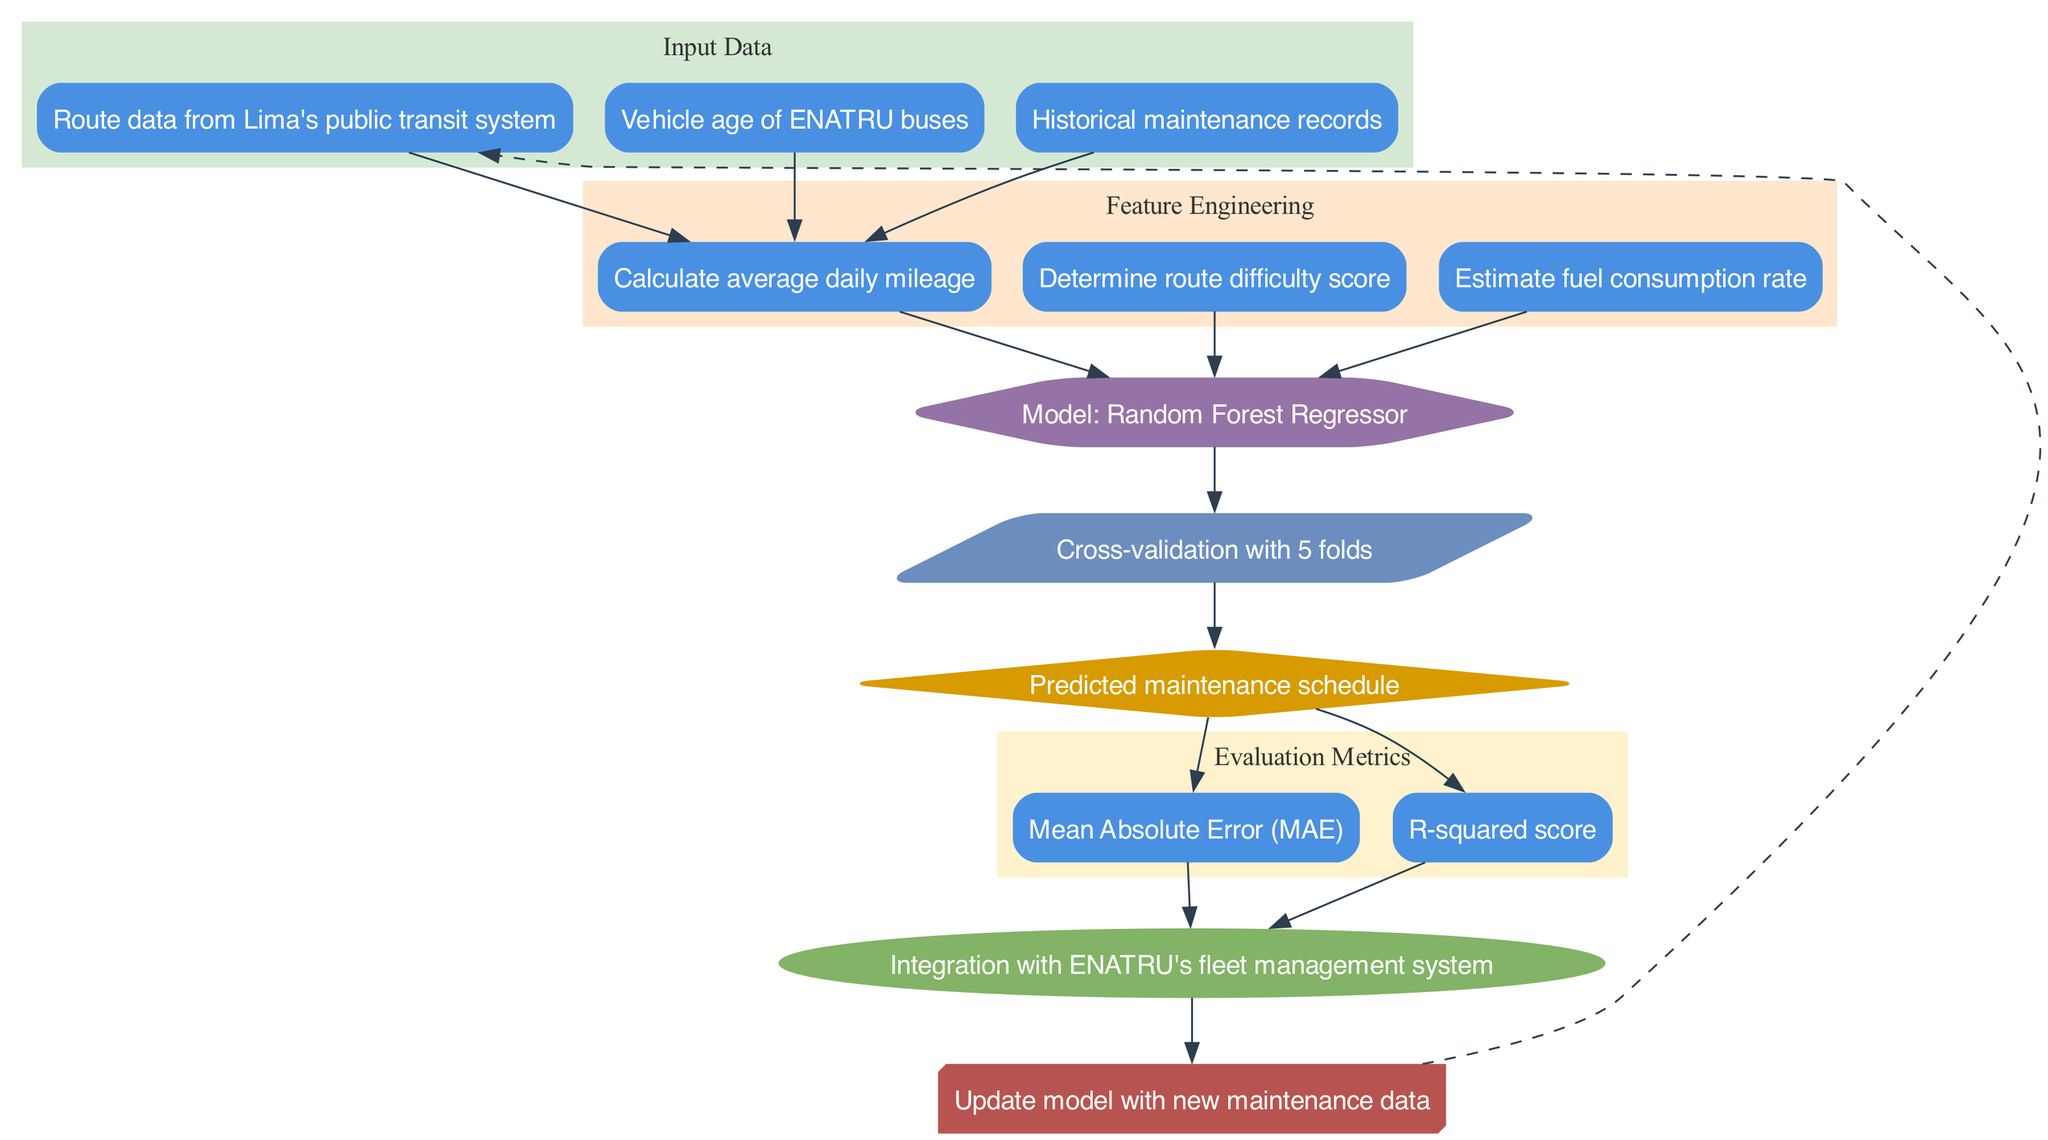What's the model used in the diagram? The diagram specifies "Random Forest Regressor" as the model. This can be identified by locating the node labeled "Model: Random Forest Regressor."
Answer: Random Forest Regressor How many features are engineered in the diagram? The diagram lists three items under the "Feature Engineering" section, which indicates that three features are being engineered.
Answer: 3 What is the evaluation metric for assessing model performance? The diagram includes "Mean Absolute Error (MAE)" as one of the evaluation metrics, which can be found in the Evaluation Metrics cluster.
Answer: Mean Absolute Error What data is used for input in the diagram? The input data includes three items: "Route data from Lima's public transit system," "Vehicle age of ENATRU buses," and "Historical maintenance records." This is evident from the "Input Data" section.
Answer: Route data from Lima's public transit system, Vehicle age of ENATRU buses, Historical maintenance records What is the relationship between the output and the evaluation metrics? In the diagram, the "Predicted maintenance schedule" is connected to both "Mean Absolute Error (MAE)" and "R-squared score," indicating that these metrics are used to evaluate the output of the model.
Answer: The output connects to both metrics How many edges are present in the deployment section of the diagram? The deployment node connects from two different evaluation metrics, indicating there are two edges present leading to the deployment section.
Answer: 2 What's the purpose of the feedback loop shown in the diagram? The feedback loop is used to "Update model with new maintenance data," as mentioned in the diagram, indicating its role in continually improving the model based on real-world data.
Answer: Update model with new maintenance data What type of graph is utilized for organizing nodes in the diagram? The diagram uses a directed graph, as indicated by the presence of arrows showing the flow of data from one node to another.
Answer: Directed graph What type of data is used to calculate the average daily mileage according to the diagram? The average daily mileage is engineered from the input data, specifically the "Route data from Lima's public transit system." This relationship can be seen from the flow of edges connecting the nodes.
Answer: Route data from Lima's public transit system 